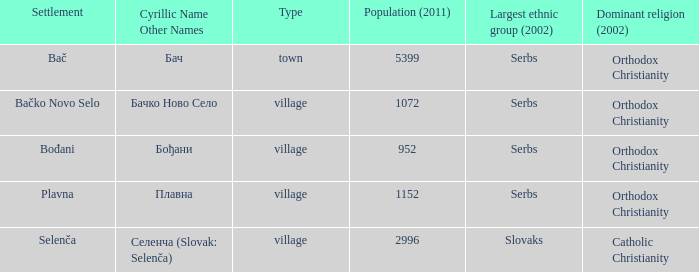What is the predominant ethnicity in the sole town? Serbs. 